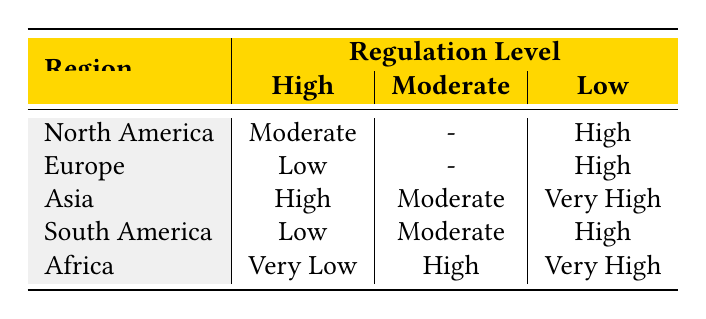What is the market volatility for North America under high regulation? In the table, we look under the "North America" row and find the "High" column for regulation level. The corresponding market volatility listed is "Moderate."
Answer: Moderate Which region has the lowest market volatility at high regulation? By examining the "High" column across the regions, we see "Very Low" listed for Africa, which is the lowest value present in that column.
Answer: Africa How many regions exhibit high market volatility under low regulation? Looking at the "Low" column, we find that three regions: Asia, South America, and Africa show high or very high volatility under low regulation levels.
Answer: Three If you combine the market volatility values for regions with moderate regulation, what is the average? The values under moderate regulation are "High" (for Africa), "Moderate" (for Asia), and "Moderate" (for South America) which we treat as High=3, Moderate=2, Low=1. Adding these gives 3 + 2 + 2 = 7, and dividing by 3 regions gives an average of approximately 2.33, corresponding to "Moderate."
Answer: Moderate Is it true that Europe has higher market volatility under high regulation compared to South America? In the "High" regulation column, Europe has "Low" volatility and South America has "Low," therefore, both are equal and the statement is false.
Answer: No What is the relationship between regulation levels and market volatility for Asia? Analyzing the row for Asia, we see that at high regulation, it has "High" volatility; at moderate, it has "Moderate"; and at low, it has "Very High." This suggests a trend where lower regulation leads to higher volatility.
Answer: Lower regulation correlates with higher volatility How does North America's market volatility compare to Africa's at moderate regulation? North America does not have a value listed for moderate regulation, while Africa shows "High" volatility. Therefore, we conclude there is no comparison as North America's data is not available.
Answer: No comparison available What is the market volatility for South America under high regulation? Checking the "High" regulation column for South America, we find "Low," meaning there is lower market volatility in this case.
Answer: Low 